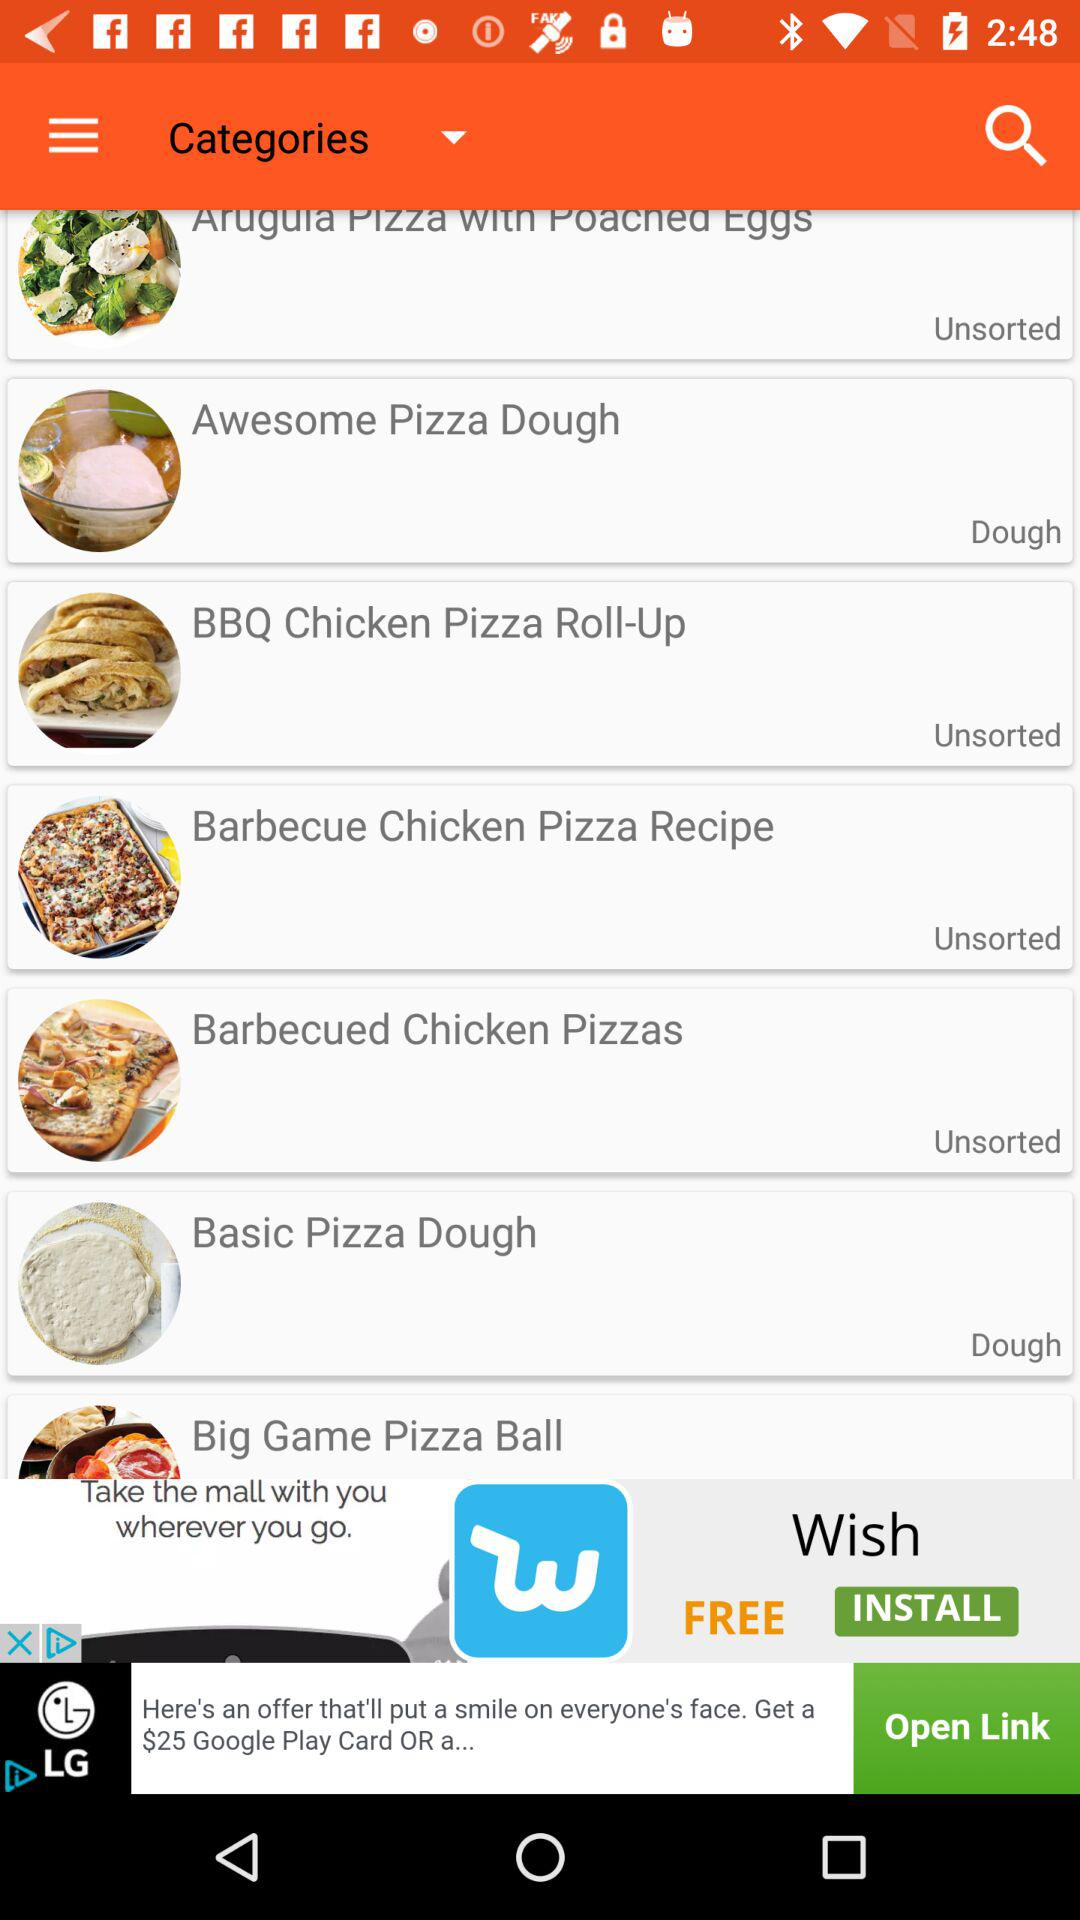Which type of recipe is "BBQ Chicken Pizza Roll-Up"? The type of recipe is "Unsorted". 